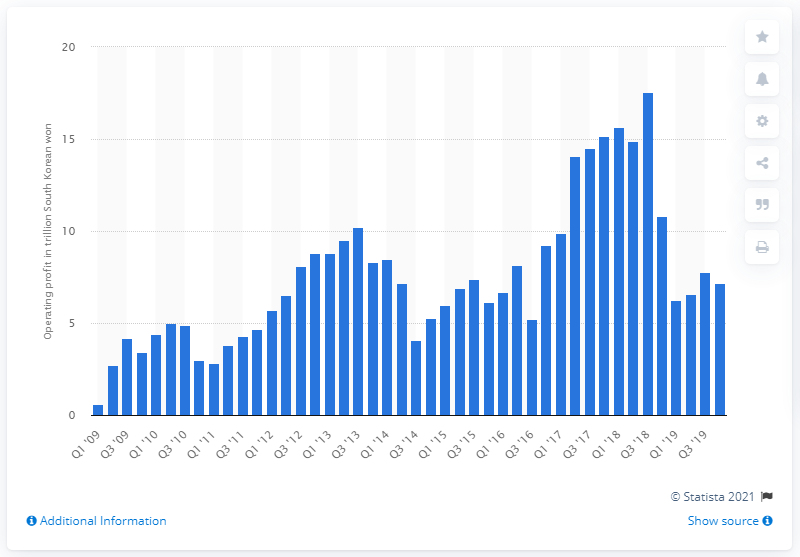Highlight a few significant elements in this photo. Samsung Electronics reported an operating profit of 7.16 trillion Korean won in the fourth quarter of 2019. 